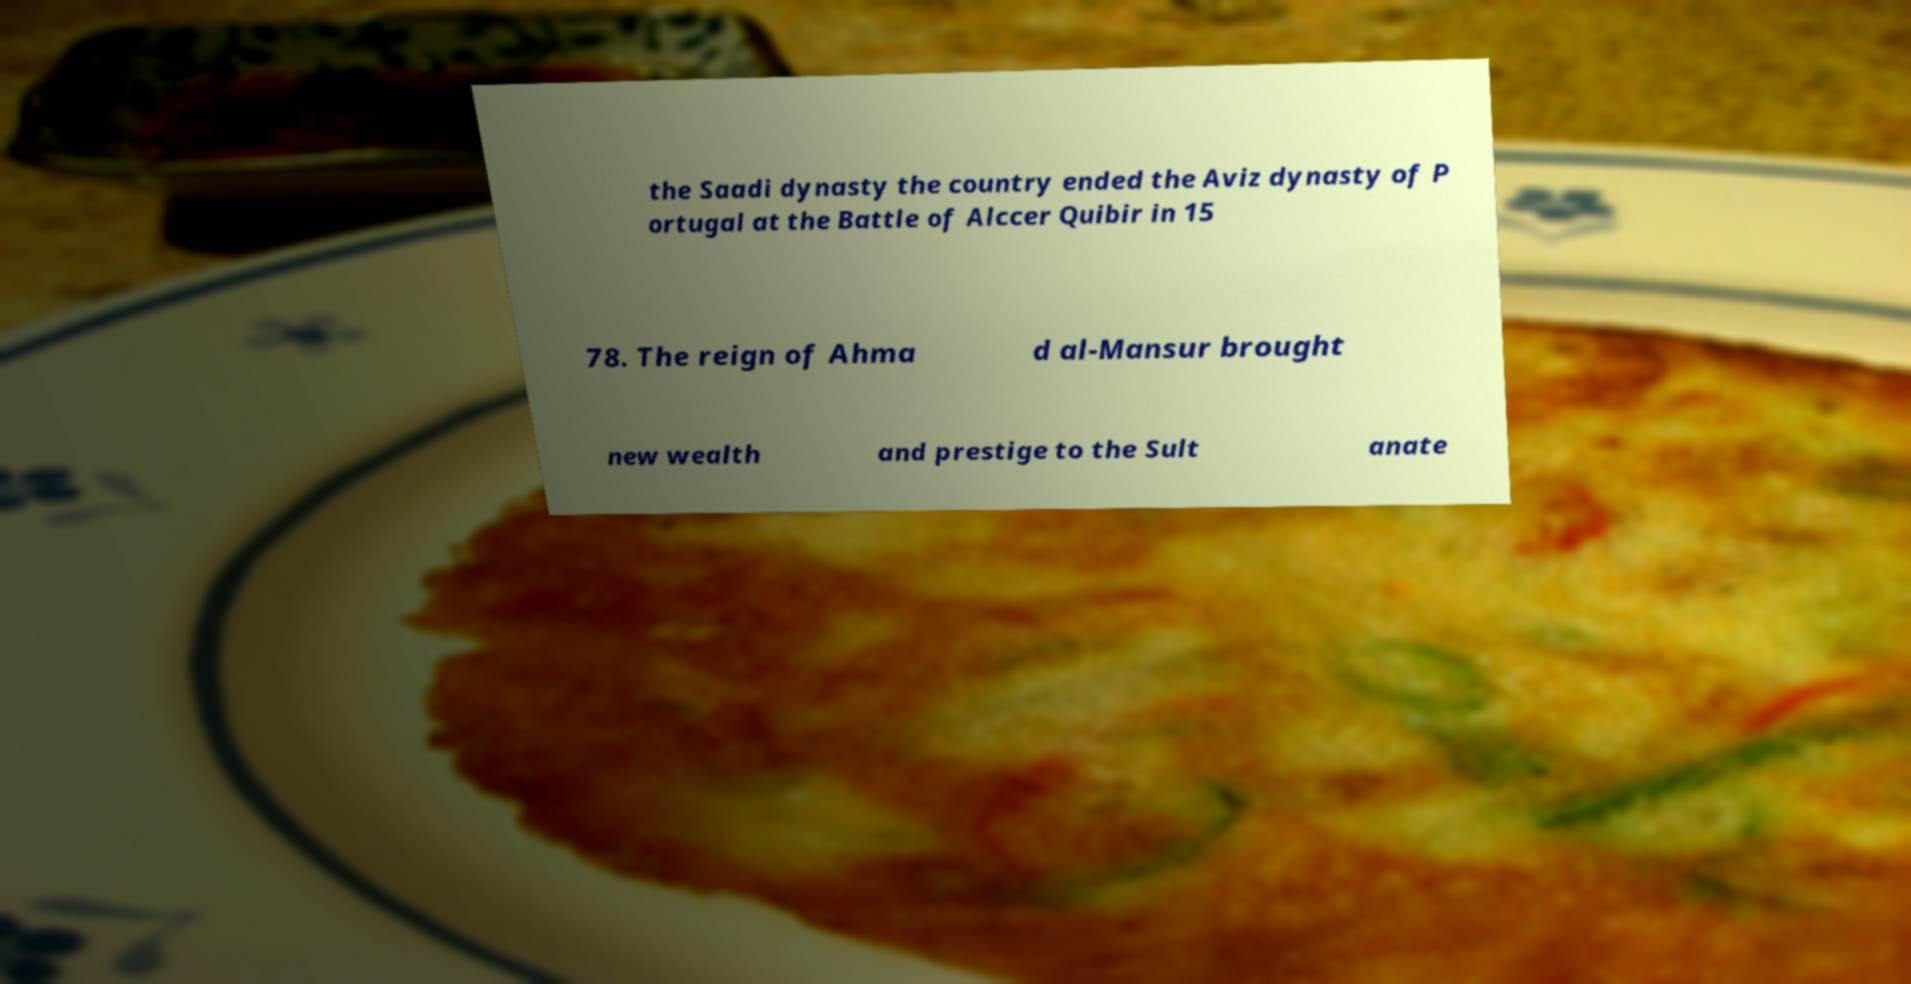Could you extract and type out the text from this image? the Saadi dynasty the country ended the Aviz dynasty of P ortugal at the Battle of Alccer Quibir in 15 78. The reign of Ahma d al-Mansur brought new wealth and prestige to the Sult anate 